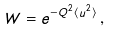Convert formula to latex. <formula><loc_0><loc_0><loc_500><loc_500>W = e ^ { - Q ^ { 2 } \langle u ^ { 2 } \rangle } \, ,</formula> 